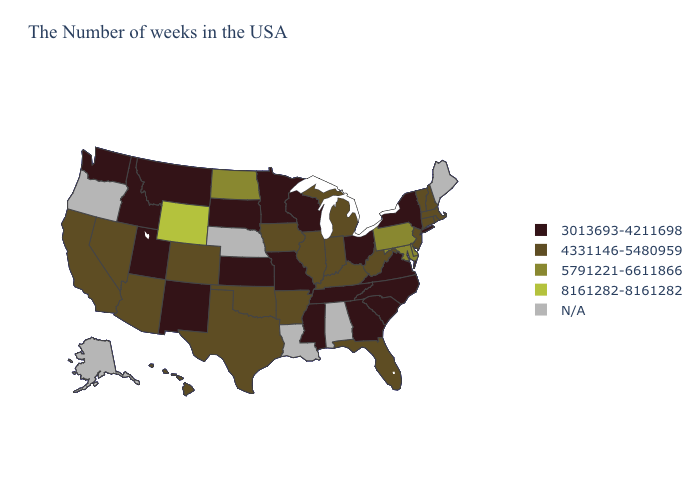How many symbols are there in the legend?
Concise answer only. 5. Among the states that border Georgia , which have the lowest value?
Write a very short answer. North Carolina, South Carolina, Tennessee. Name the states that have a value in the range 5791221-6611866?
Answer briefly. Delaware, Maryland, Pennsylvania, North Dakota. Does the map have missing data?
Concise answer only. Yes. Does Minnesota have the lowest value in the MidWest?
Short answer required. Yes. What is the highest value in the USA?
Keep it brief. 8161282-8161282. Which states hav the highest value in the Northeast?
Keep it brief. Pennsylvania. Name the states that have a value in the range 4331146-5480959?
Give a very brief answer. Massachusetts, Rhode Island, New Hampshire, Vermont, Connecticut, New Jersey, West Virginia, Florida, Michigan, Kentucky, Indiana, Illinois, Arkansas, Iowa, Oklahoma, Texas, Colorado, Arizona, Nevada, California, Hawaii. Does Washington have the lowest value in the USA?
Be succinct. Yes. What is the highest value in the USA?
Short answer required. 8161282-8161282. Does the first symbol in the legend represent the smallest category?
Quick response, please. Yes. What is the value of Illinois?
Be succinct. 4331146-5480959. What is the highest value in states that border North Carolina?
Keep it brief. 3013693-4211698. What is the value of Massachusetts?
Answer briefly. 4331146-5480959. Does the map have missing data?
Short answer required. Yes. 